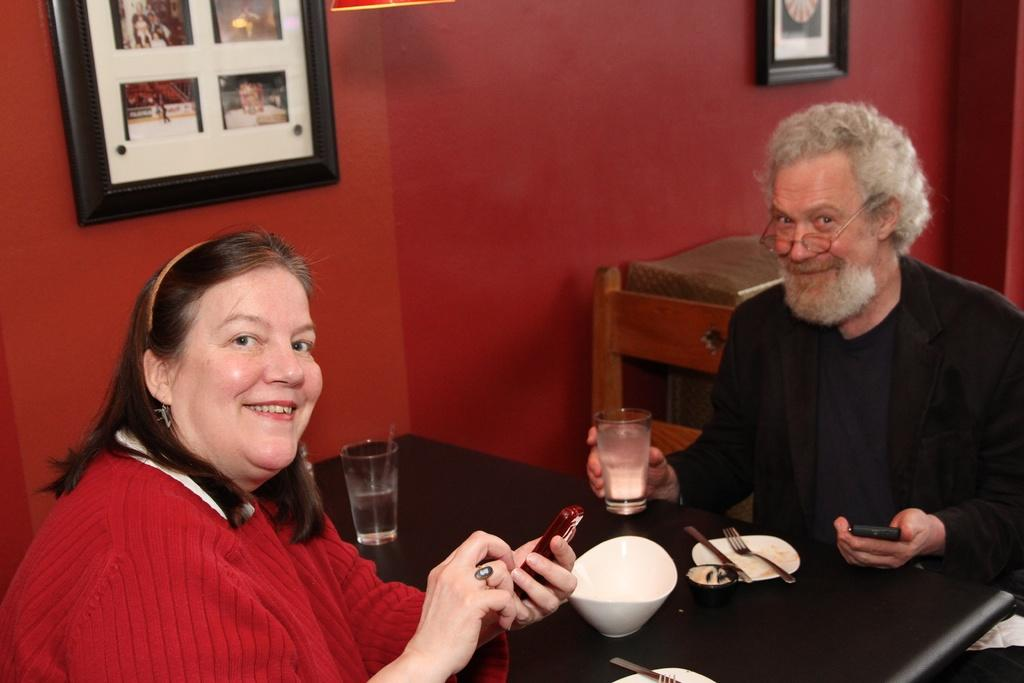What color is the wall in the image? The wall in the image is red. What object can be seen hanging on the wall? There is a photo frame in the image. How many people are sitting in the image? There are two people sitting on chairs in the image. What piece of furniture is present in the image? There is a table in the image. What items can be found on the table? On the table, there is a bowl, a plate, a fork, a spoon, and glasses. What type of thrill can be seen on the faces of the people in the image? There is no indication of any thrill or emotion on the faces of the people in the image. What credit card is being used to pay for the items on the table? There is no credit card or payment method visible in the image. 